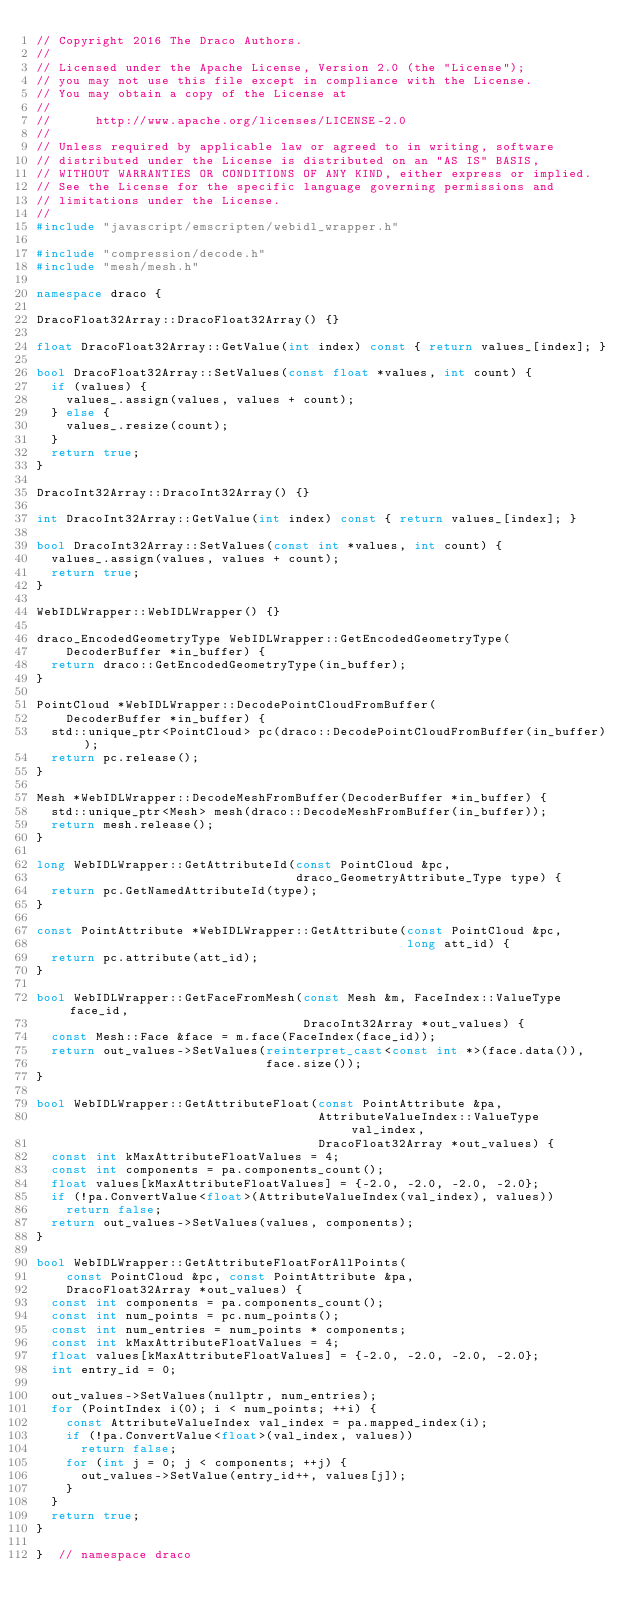Convert code to text. <code><loc_0><loc_0><loc_500><loc_500><_C++_>// Copyright 2016 The Draco Authors.
//
// Licensed under the Apache License, Version 2.0 (the "License");
// you may not use this file except in compliance with the License.
// You may obtain a copy of the License at
//
//      http://www.apache.org/licenses/LICENSE-2.0
//
// Unless required by applicable law or agreed to in writing, software
// distributed under the License is distributed on an "AS IS" BASIS,
// WITHOUT WARRANTIES OR CONDITIONS OF ANY KIND, either express or implied.
// See the License for the specific language governing permissions and
// limitations under the License.
//
#include "javascript/emscripten/webidl_wrapper.h"

#include "compression/decode.h"
#include "mesh/mesh.h"

namespace draco {

DracoFloat32Array::DracoFloat32Array() {}

float DracoFloat32Array::GetValue(int index) const { return values_[index]; }

bool DracoFloat32Array::SetValues(const float *values, int count) {
  if (values) {
    values_.assign(values, values + count);
  } else {
    values_.resize(count);
  }
  return true;
}

DracoInt32Array::DracoInt32Array() {}

int DracoInt32Array::GetValue(int index) const { return values_[index]; }

bool DracoInt32Array::SetValues(const int *values, int count) {
  values_.assign(values, values + count);
  return true;
}

WebIDLWrapper::WebIDLWrapper() {}

draco_EncodedGeometryType WebIDLWrapper::GetEncodedGeometryType(
    DecoderBuffer *in_buffer) {
  return draco::GetEncodedGeometryType(in_buffer);
}

PointCloud *WebIDLWrapper::DecodePointCloudFromBuffer(
    DecoderBuffer *in_buffer) {
  std::unique_ptr<PointCloud> pc(draco::DecodePointCloudFromBuffer(in_buffer));
  return pc.release();
}

Mesh *WebIDLWrapper::DecodeMeshFromBuffer(DecoderBuffer *in_buffer) {
  std::unique_ptr<Mesh> mesh(draco::DecodeMeshFromBuffer(in_buffer));
  return mesh.release();
}

long WebIDLWrapper::GetAttributeId(const PointCloud &pc,
                                   draco_GeometryAttribute_Type type) {
  return pc.GetNamedAttributeId(type);
}

const PointAttribute *WebIDLWrapper::GetAttribute(const PointCloud &pc,
                                                  long att_id) {
  return pc.attribute(att_id);
}

bool WebIDLWrapper::GetFaceFromMesh(const Mesh &m, FaceIndex::ValueType face_id,
                                    DracoInt32Array *out_values) {
  const Mesh::Face &face = m.face(FaceIndex(face_id));
  return out_values->SetValues(reinterpret_cast<const int *>(face.data()),
                               face.size());
}

bool WebIDLWrapper::GetAttributeFloat(const PointAttribute &pa,
                                      AttributeValueIndex::ValueType val_index,
                                      DracoFloat32Array *out_values) {
  const int kMaxAttributeFloatValues = 4;
  const int components = pa.components_count();
  float values[kMaxAttributeFloatValues] = {-2.0, -2.0, -2.0, -2.0};
  if (!pa.ConvertValue<float>(AttributeValueIndex(val_index), values))
    return false;
  return out_values->SetValues(values, components);
}

bool WebIDLWrapper::GetAttributeFloatForAllPoints(
    const PointCloud &pc, const PointAttribute &pa,
    DracoFloat32Array *out_values) {
  const int components = pa.components_count();
  const int num_points = pc.num_points();
  const int num_entries = num_points * components;
  const int kMaxAttributeFloatValues = 4;
  float values[kMaxAttributeFloatValues] = {-2.0, -2.0, -2.0, -2.0};
  int entry_id = 0;

  out_values->SetValues(nullptr, num_entries);
  for (PointIndex i(0); i < num_points; ++i) {
    const AttributeValueIndex val_index = pa.mapped_index(i);
    if (!pa.ConvertValue<float>(val_index, values))
      return false;
    for (int j = 0; j < components; ++j) {
      out_values->SetValue(entry_id++, values[j]);
    }
  }
  return true;
}

}  // namespace draco
</code> 